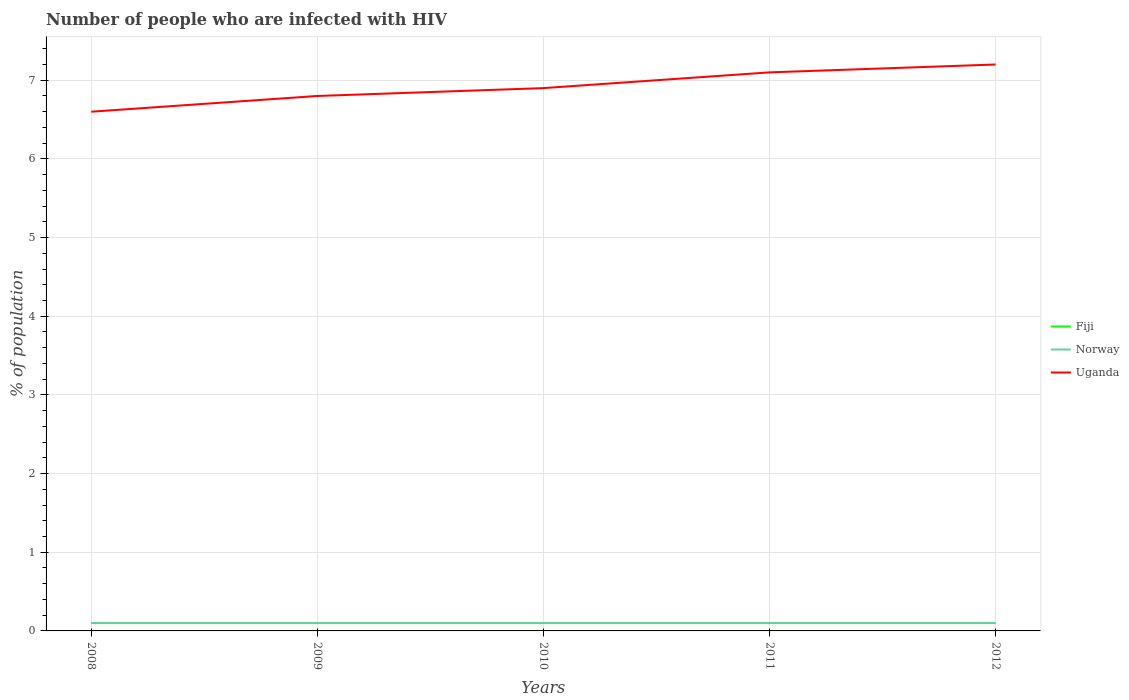How many different coloured lines are there?
Your response must be concise. 3. Does the line corresponding to Fiji intersect with the line corresponding to Uganda?
Make the answer very short. No. Across all years, what is the maximum percentage of HIV infected population in in Uganda?
Your response must be concise. 6.6. In which year was the percentage of HIV infected population in in Fiji maximum?
Offer a terse response. 2008. What is the total percentage of HIV infected population in in Uganda in the graph?
Your response must be concise. -0.4. What is the difference between the highest and the second highest percentage of HIV infected population in in Uganda?
Keep it short and to the point. 0.6. What is the difference between two consecutive major ticks on the Y-axis?
Keep it short and to the point. 1. Does the graph contain any zero values?
Provide a short and direct response. No. Does the graph contain grids?
Make the answer very short. Yes. What is the title of the graph?
Keep it short and to the point. Number of people who are infected with HIV. Does "Bosnia and Herzegovina" appear as one of the legend labels in the graph?
Provide a short and direct response. No. What is the label or title of the X-axis?
Keep it short and to the point. Years. What is the label or title of the Y-axis?
Make the answer very short. % of population. What is the % of population of Norway in 2008?
Provide a succinct answer. 0.1. What is the % of population of Fiji in 2009?
Keep it short and to the point. 0.1. What is the % of population of Norway in 2009?
Offer a terse response. 0.1. What is the % of population in Uganda in 2009?
Offer a terse response. 6.8. What is the % of population in Fiji in 2011?
Give a very brief answer. 0.1. What is the % of population in Norway in 2012?
Make the answer very short. 0.1. Across all years, what is the maximum % of population in Norway?
Give a very brief answer. 0.1. Across all years, what is the minimum % of population in Norway?
Offer a terse response. 0.1. Across all years, what is the minimum % of population in Uganda?
Ensure brevity in your answer.  6.6. What is the total % of population in Fiji in the graph?
Give a very brief answer. 0.5. What is the total % of population of Uganda in the graph?
Your answer should be very brief. 34.6. What is the difference between the % of population of Fiji in 2008 and that in 2009?
Provide a succinct answer. 0. What is the difference between the % of population of Uganda in 2008 and that in 2009?
Your answer should be very brief. -0.2. What is the difference between the % of population of Fiji in 2008 and that in 2010?
Keep it short and to the point. 0. What is the difference between the % of population in Norway in 2008 and that in 2010?
Provide a short and direct response. 0. What is the difference between the % of population in Norway in 2008 and that in 2011?
Ensure brevity in your answer.  0. What is the difference between the % of population in Uganda in 2008 and that in 2011?
Offer a very short reply. -0.5. What is the difference between the % of population of Norway in 2008 and that in 2012?
Your response must be concise. 0. What is the difference between the % of population of Norway in 2009 and that in 2010?
Make the answer very short. 0. What is the difference between the % of population of Uganda in 2009 and that in 2010?
Give a very brief answer. -0.1. What is the difference between the % of population in Fiji in 2009 and that in 2011?
Provide a short and direct response. 0. What is the difference between the % of population of Fiji in 2010 and that in 2011?
Provide a succinct answer. 0. What is the difference between the % of population of Norway in 2010 and that in 2011?
Make the answer very short. 0. What is the difference between the % of population in Uganda in 2010 and that in 2011?
Make the answer very short. -0.2. What is the difference between the % of population in Norway in 2010 and that in 2012?
Your answer should be compact. 0. What is the difference between the % of population in Uganda in 2010 and that in 2012?
Offer a very short reply. -0.3. What is the difference between the % of population in Fiji in 2011 and that in 2012?
Your answer should be very brief. 0. What is the difference between the % of population of Norway in 2011 and that in 2012?
Keep it short and to the point. 0. What is the difference between the % of population of Fiji in 2008 and the % of population of Norway in 2009?
Offer a very short reply. 0. What is the difference between the % of population of Fiji in 2008 and the % of population of Uganda in 2009?
Provide a short and direct response. -6.7. What is the difference between the % of population of Fiji in 2008 and the % of population of Norway in 2010?
Offer a very short reply. 0. What is the difference between the % of population of Fiji in 2008 and the % of population of Uganda in 2010?
Your response must be concise. -6.8. What is the difference between the % of population of Fiji in 2008 and the % of population of Uganda in 2012?
Your response must be concise. -7.1. What is the difference between the % of population of Fiji in 2009 and the % of population of Uganda in 2011?
Keep it short and to the point. -7. What is the difference between the % of population in Norway in 2009 and the % of population in Uganda in 2011?
Ensure brevity in your answer.  -7. What is the difference between the % of population in Fiji in 2009 and the % of population in Uganda in 2012?
Offer a terse response. -7.1. What is the difference between the % of population of Fiji in 2010 and the % of population of Norway in 2011?
Make the answer very short. 0. What is the difference between the % of population in Norway in 2010 and the % of population in Uganda in 2012?
Ensure brevity in your answer.  -7.1. What is the difference between the % of population of Fiji in 2011 and the % of population of Norway in 2012?
Offer a very short reply. 0. What is the difference between the % of population of Fiji in 2011 and the % of population of Uganda in 2012?
Provide a succinct answer. -7.1. What is the difference between the % of population in Norway in 2011 and the % of population in Uganda in 2012?
Offer a very short reply. -7.1. What is the average % of population in Norway per year?
Make the answer very short. 0.1. What is the average % of population in Uganda per year?
Provide a succinct answer. 6.92. In the year 2008, what is the difference between the % of population of Fiji and % of population of Uganda?
Keep it short and to the point. -6.5. In the year 2008, what is the difference between the % of population of Norway and % of population of Uganda?
Ensure brevity in your answer.  -6.5. In the year 2010, what is the difference between the % of population in Fiji and % of population in Norway?
Your answer should be compact. 0. In the year 2010, what is the difference between the % of population of Fiji and % of population of Uganda?
Your response must be concise. -6.8. In the year 2010, what is the difference between the % of population in Norway and % of population in Uganda?
Provide a short and direct response. -6.8. In the year 2011, what is the difference between the % of population in Fiji and % of population in Norway?
Make the answer very short. 0. In the year 2011, what is the difference between the % of population of Fiji and % of population of Uganda?
Ensure brevity in your answer.  -7. In the year 2012, what is the difference between the % of population of Fiji and % of population of Norway?
Offer a very short reply. 0. What is the ratio of the % of population in Fiji in 2008 to that in 2009?
Give a very brief answer. 1. What is the ratio of the % of population in Norway in 2008 to that in 2009?
Your response must be concise. 1. What is the ratio of the % of population in Uganda in 2008 to that in 2009?
Keep it short and to the point. 0.97. What is the ratio of the % of population in Uganda in 2008 to that in 2010?
Ensure brevity in your answer.  0.96. What is the ratio of the % of population in Fiji in 2008 to that in 2011?
Keep it short and to the point. 1. What is the ratio of the % of population in Norway in 2008 to that in 2011?
Give a very brief answer. 1. What is the ratio of the % of population in Uganda in 2008 to that in 2011?
Offer a very short reply. 0.93. What is the ratio of the % of population in Fiji in 2008 to that in 2012?
Your response must be concise. 1. What is the ratio of the % of population of Norway in 2008 to that in 2012?
Provide a short and direct response. 1. What is the ratio of the % of population in Uganda in 2008 to that in 2012?
Offer a terse response. 0.92. What is the ratio of the % of population in Fiji in 2009 to that in 2010?
Provide a succinct answer. 1. What is the ratio of the % of population of Norway in 2009 to that in 2010?
Make the answer very short. 1. What is the ratio of the % of population in Uganda in 2009 to that in 2010?
Give a very brief answer. 0.99. What is the ratio of the % of population of Fiji in 2009 to that in 2011?
Offer a terse response. 1. What is the ratio of the % of population of Uganda in 2009 to that in 2011?
Offer a terse response. 0.96. What is the ratio of the % of population of Fiji in 2009 to that in 2012?
Ensure brevity in your answer.  1. What is the ratio of the % of population of Norway in 2009 to that in 2012?
Your answer should be compact. 1. What is the ratio of the % of population of Uganda in 2009 to that in 2012?
Your response must be concise. 0.94. What is the ratio of the % of population in Uganda in 2010 to that in 2011?
Make the answer very short. 0.97. What is the ratio of the % of population of Uganda in 2010 to that in 2012?
Offer a terse response. 0.96. What is the ratio of the % of population of Fiji in 2011 to that in 2012?
Keep it short and to the point. 1. What is the ratio of the % of population in Norway in 2011 to that in 2012?
Ensure brevity in your answer.  1. What is the ratio of the % of population in Uganda in 2011 to that in 2012?
Give a very brief answer. 0.99. What is the difference between the highest and the second highest % of population in Norway?
Your answer should be very brief. 0. What is the difference between the highest and the lowest % of population in Norway?
Your response must be concise. 0. 